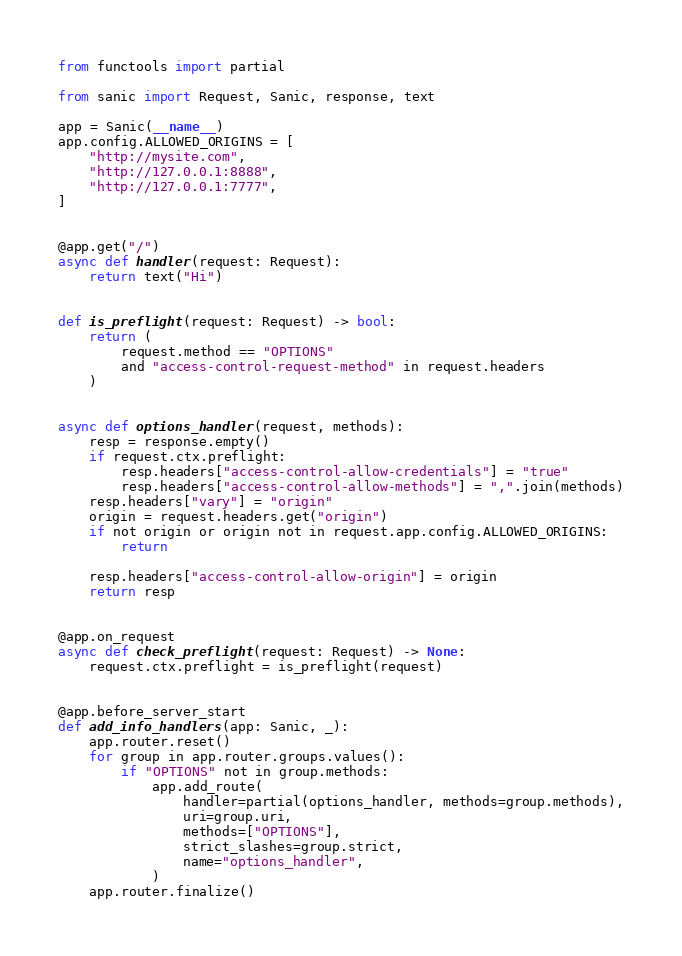<code> <loc_0><loc_0><loc_500><loc_500><_Python_>from functools import partial

from sanic import Request, Sanic, response, text

app = Sanic(__name__)
app.config.ALLOWED_ORIGINS = [
    "http://mysite.com",
    "http://127.0.0.1:8888",
    "http://127.0.0.1:7777",
]


@app.get("/")
async def handler(request: Request):
    return text("Hi")


def is_preflight(request: Request) -> bool:
    return (
        request.method == "OPTIONS"
        and "access-control-request-method" in request.headers
    )


async def options_handler(request, methods):
    resp = response.empty()
    if request.ctx.preflight:
        resp.headers["access-control-allow-credentials"] = "true"
        resp.headers["access-control-allow-methods"] = ",".join(methods)
    resp.headers["vary"] = "origin"
    origin = request.headers.get("origin")
    if not origin or origin not in request.app.config.ALLOWED_ORIGINS:
        return

    resp.headers["access-control-allow-origin"] = origin
    return resp


@app.on_request
async def check_preflight(request: Request) -> None:
    request.ctx.preflight = is_preflight(request)


@app.before_server_start
def add_info_handlers(app: Sanic, _):
    app.router.reset()
    for group in app.router.groups.values():
        if "OPTIONS" not in group.methods:
            app.add_route(
                handler=partial(options_handler, methods=group.methods),
                uri=group.uri,
                methods=["OPTIONS"],
                strict_slashes=group.strict,
                name="options_handler",
            )
    app.router.finalize()
</code> 